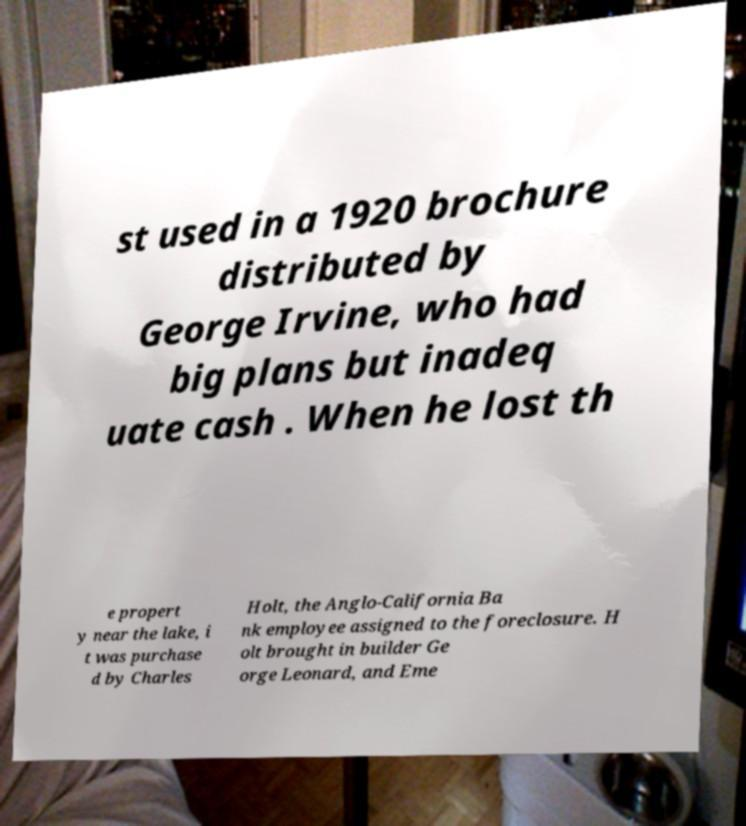Please read and relay the text visible in this image. What does it say? st used in a 1920 brochure distributed by George Irvine, who had big plans but inadeq uate cash . When he lost th e propert y near the lake, i t was purchase d by Charles Holt, the Anglo-California Ba nk employee assigned to the foreclosure. H olt brought in builder Ge orge Leonard, and Eme 